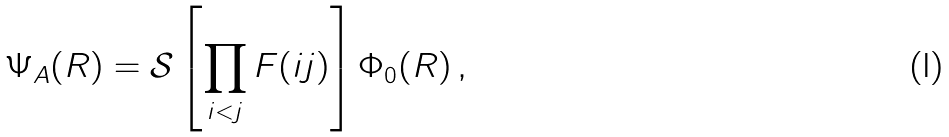<formula> <loc_0><loc_0><loc_500><loc_500>\Psi _ { A } ( R ) = { \mathcal { S } } \left [ \prod _ { i < j } F ( i j ) \right ] \Phi _ { 0 } ( R ) \, ,</formula> 